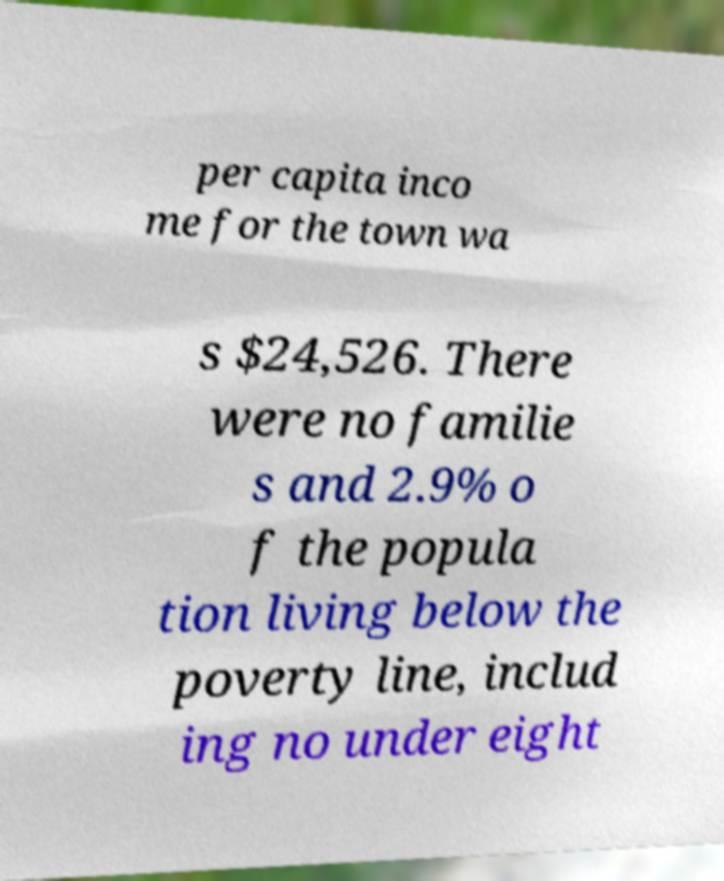Can you read and provide the text displayed in the image?This photo seems to have some interesting text. Can you extract and type it out for me? per capita inco me for the town wa s $24,526. There were no familie s and 2.9% o f the popula tion living below the poverty line, includ ing no under eight 